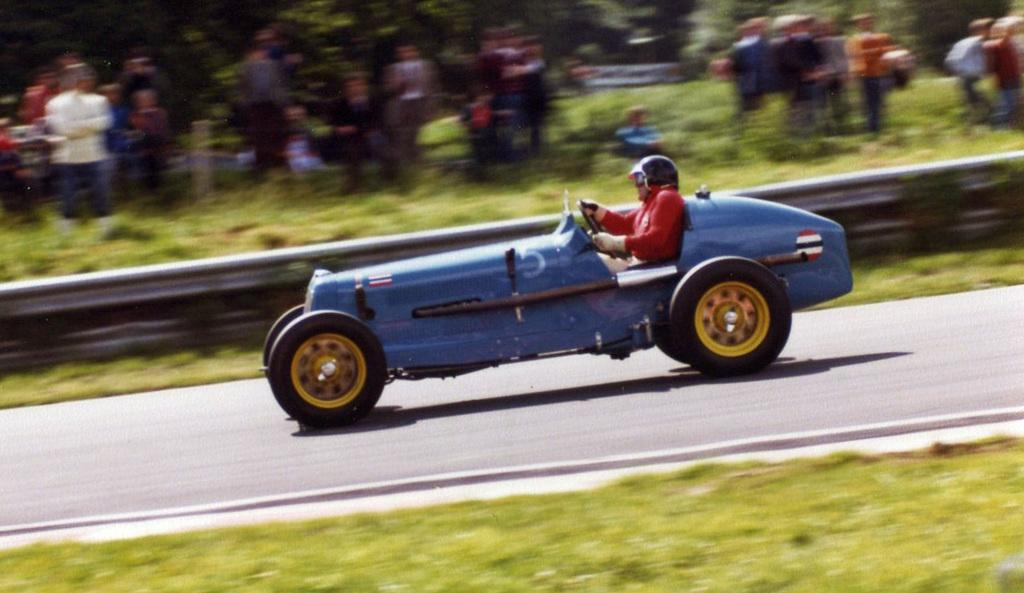What is the person in the image doing? There is a person riding a car in the image. Where is the car located? The car is on the road. Can you describe the environment around the car? There are surrounding people visible in the image. What type of surface can be seen in the image? There is a grassy surface in the image. Where is the lunchroom located in the image? There is no lunchroom present in the image. What type of lumber is being used to build the car in the image? The car in the image is not made of lumber; it is a typical car. 